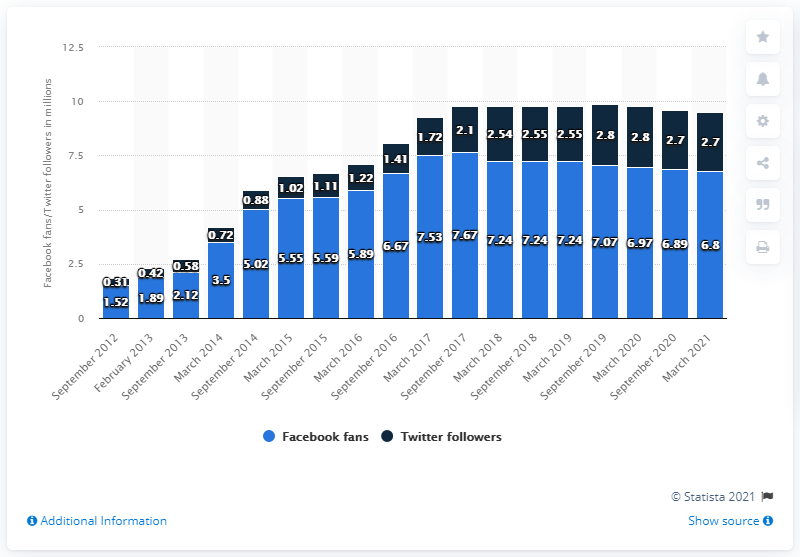Specify some key components in this picture. In March 2021, the Oklahoma City Thunder had 6.8 fans on their Facebook page. The Oklahoma City Thunder established their Facebook page in September 2012. The light blue color on Facebook indicates the number of fans a page has. The sum of the first and last blue bars in the chart is 8.32. 